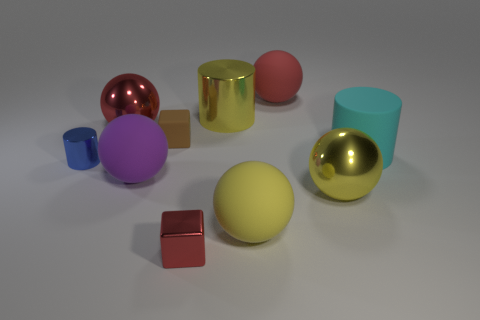Subtract all big cyan cylinders. How many cylinders are left? 2 Subtract 3 spheres. How many spheres are left? 2 Subtract all red blocks. How many blocks are left? 1 Subtract all cubes. How many objects are left? 8 Add 6 red spheres. How many red spheres are left? 8 Add 1 large matte spheres. How many large matte spheres exist? 4 Subtract 0 brown cylinders. How many objects are left? 10 Subtract all cyan blocks. Subtract all green cylinders. How many blocks are left? 2 Subtract all yellow cubes. How many yellow balls are left? 2 Subtract all tiny brown cubes. Subtract all blue metal things. How many objects are left? 8 